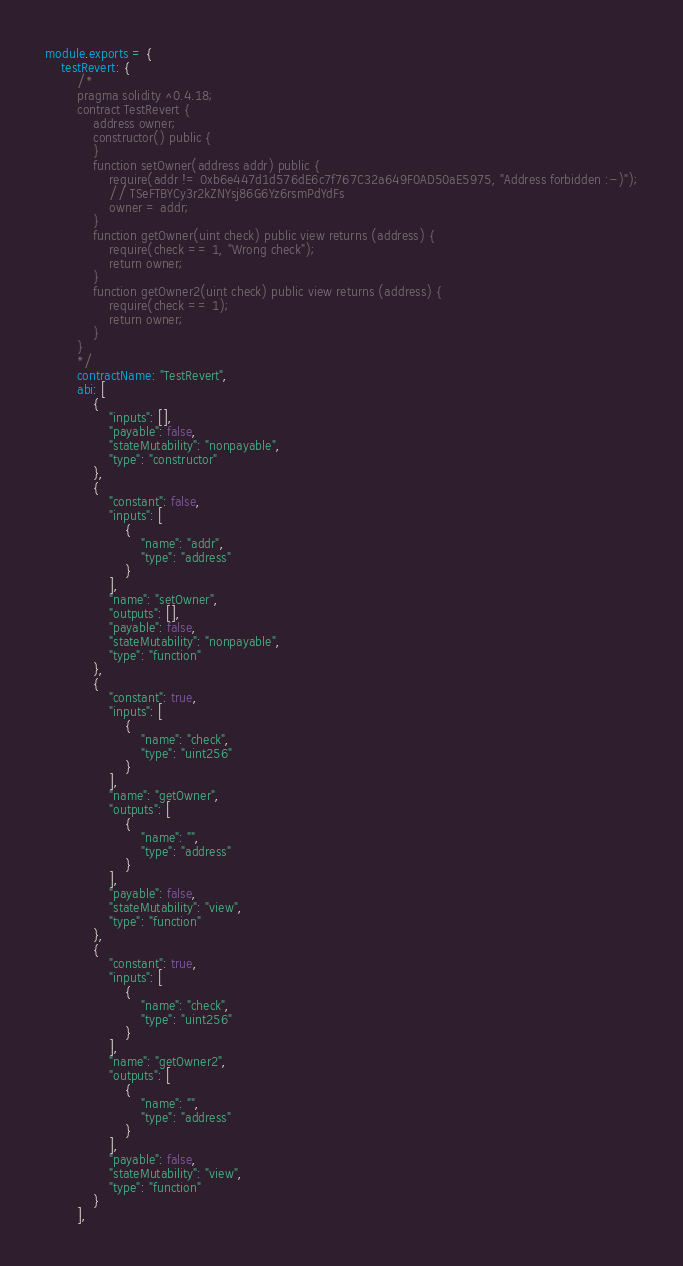<code> <loc_0><loc_0><loc_500><loc_500><_JavaScript_>module.exports = {
    testRevert: {
        /*
        pragma solidity ^0.4.18;
        contract TestRevert {
            address owner;
            constructor() public {
            }
            function setOwner(address addr) public {
                require(addr != 0xb6e447d1d576dE6c7f767C32a649F0AD50aE5975, "Address forbidden :-)");
                // TSeFTBYCy3r2kZNYsj86G6Yz6rsmPdYdFs
                owner = addr;
            }
            function getOwner(uint check) public view returns (address) {
                require(check == 1, "Wrong check");
                return owner;
            }
            function getOwner2(uint check) public view returns (address) {
                require(check == 1);
                return owner;
            }
        }
        */
        contractName: "TestRevert",
        abi: [
            {
                "inputs": [],
                "payable": false,
                "stateMutability": "nonpayable",
                "type": "constructor"
            },
            {
                "constant": false,
                "inputs": [
                    {
                        "name": "addr",
                        "type": "address"
                    }
                ],
                "name": "setOwner",
                "outputs": [],
                "payable": false,
                "stateMutability": "nonpayable",
                "type": "function"
            },
            {
                "constant": true,
                "inputs": [
                    {
                        "name": "check",
                        "type": "uint256"
                    }
                ],
                "name": "getOwner",
                "outputs": [
                    {
                        "name": "",
                        "type": "address"
                    }
                ],
                "payable": false,
                "stateMutability": "view",
                "type": "function"
            },
            {
                "constant": true,
                "inputs": [
                    {
                        "name": "check",
                        "type": "uint256"
                    }
                ],
                "name": "getOwner2",
                "outputs": [
                    {
                        "name": "",
                        "type": "address"
                    }
                ],
                "payable": false,
                "stateMutability": "view",
                "type": "function"
            }
        ],</code> 